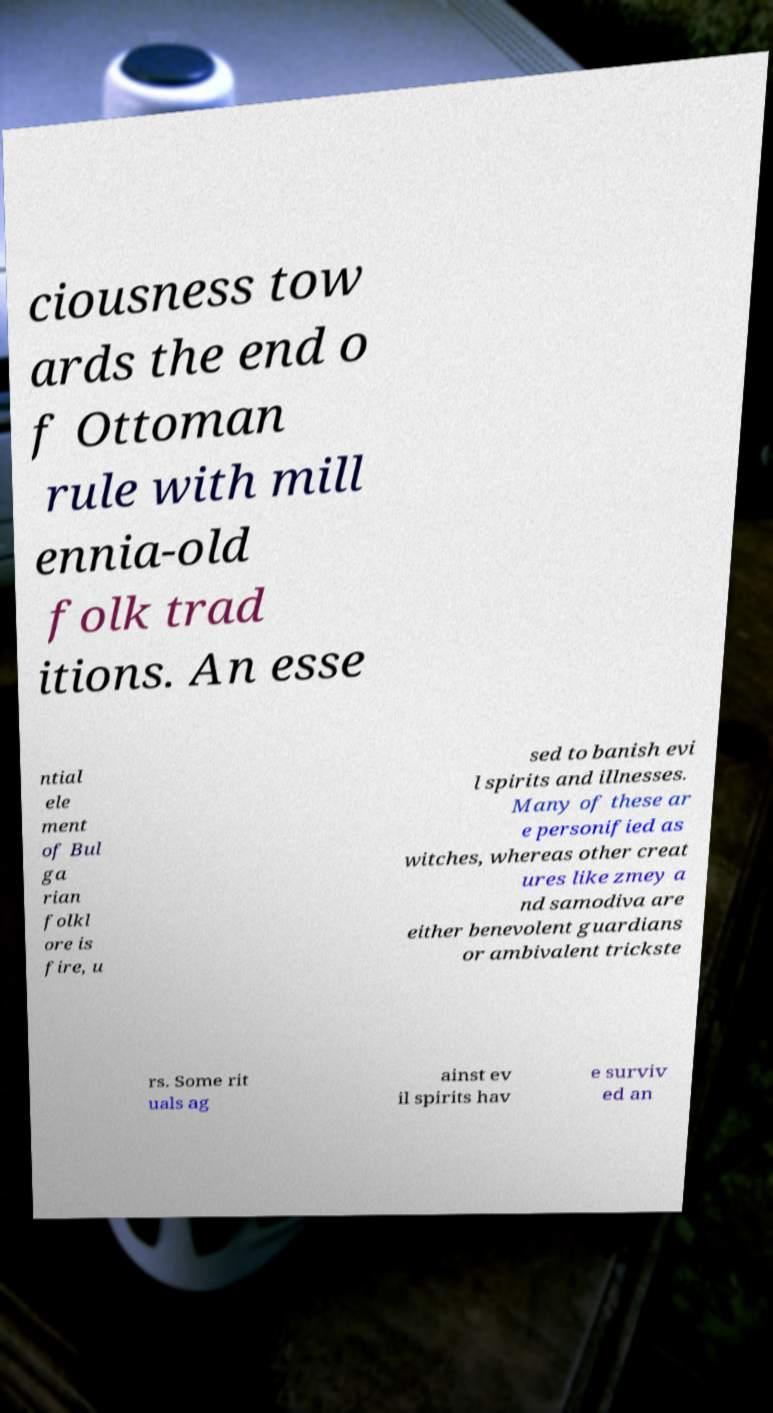Can you read and provide the text displayed in the image?This photo seems to have some interesting text. Can you extract and type it out for me? ciousness tow ards the end o f Ottoman rule with mill ennia-old folk trad itions. An esse ntial ele ment of Bul ga rian folkl ore is fire, u sed to banish evi l spirits and illnesses. Many of these ar e personified as witches, whereas other creat ures like zmey a nd samodiva are either benevolent guardians or ambivalent trickste rs. Some rit uals ag ainst ev il spirits hav e surviv ed an 